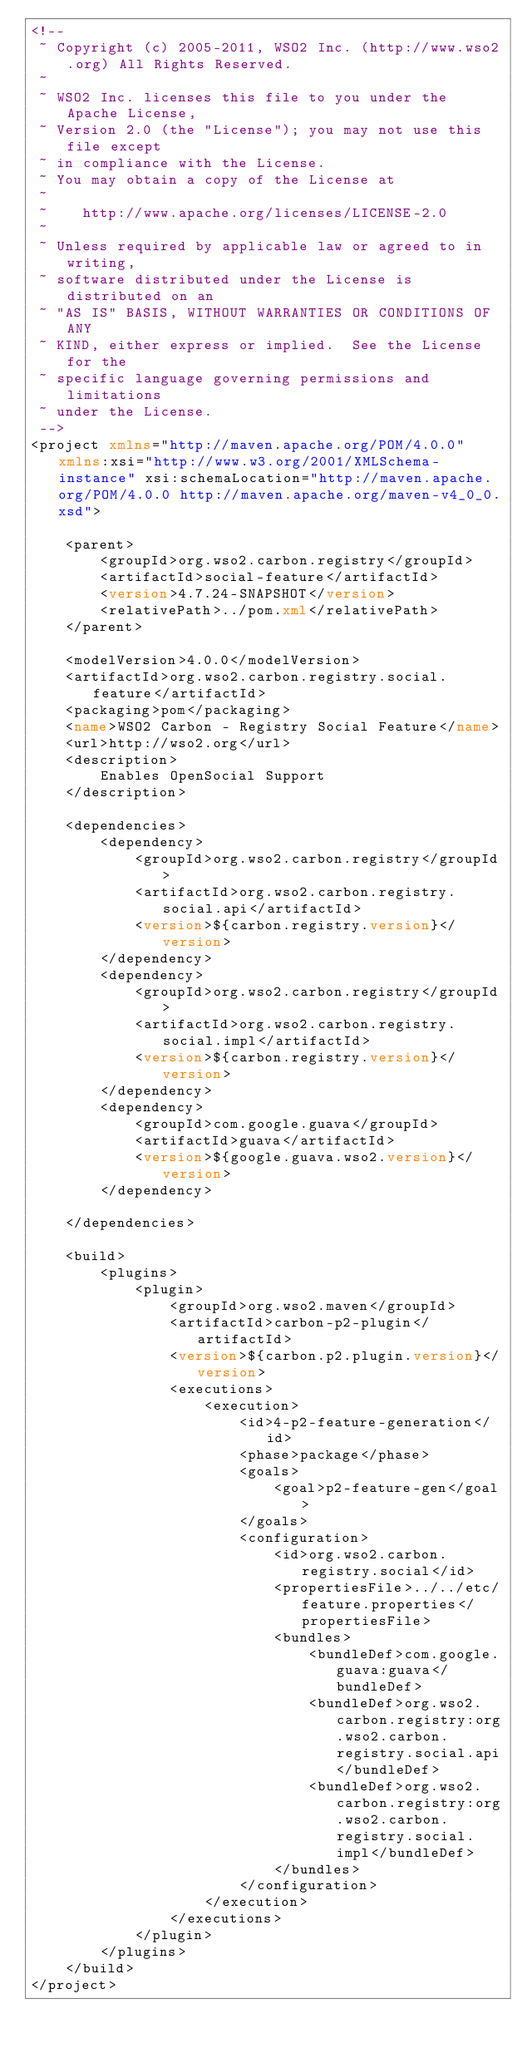Convert code to text. <code><loc_0><loc_0><loc_500><loc_500><_XML_><!--
 ~ Copyright (c) 2005-2011, WSO2 Inc. (http://www.wso2.org) All Rights Reserved.
 ~
 ~ WSO2 Inc. licenses this file to you under the Apache License,
 ~ Version 2.0 (the "License"); you may not use this file except
 ~ in compliance with the License.
 ~ You may obtain a copy of the License at
 ~
 ~    http://www.apache.org/licenses/LICENSE-2.0
 ~
 ~ Unless required by applicable law or agreed to in writing,
 ~ software distributed under the License is distributed on an
 ~ "AS IS" BASIS, WITHOUT WARRANTIES OR CONDITIONS OF ANY
 ~ KIND, either express or implied.  See the License for the
 ~ specific language governing permissions and limitations
 ~ under the License.
 -->
<project xmlns="http://maven.apache.org/POM/4.0.0" xmlns:xsi="http://www.w3.org/2001/XMLSchema-instance" xsi:schemaLocation="http://maven.apache.org/POM/4.0.0 http://maven.apache.org/maven-v4_0_0.xsd">

    <parent>
        <groupId>org.wso2.carbon.registry</groupId>
        <artifactId>social-feature</artifactId>
        <version>4.7.24-SNAPSHOT</version>
        <relativePath>../pom.xml</relativePath>
    </parent>

    <modelVersion>4.0.0</modelVersion>
    <artifactId>org.wso2.carbon.registry.social.feature</artifactId>
    <packaging>pom</packaging>
    <name>WSO2 Carbon - Registry Social Feature</name>
    <url>http://wso2.org</url>
    <description>
        Enables OpenSocial Support
    </description>

    <dependencies>
        <dependency>
            <groupId>org.wso2.carbon.registry</groupId>
            <artifactId>org.wso2.carbon.registry.social.api</artifactId>
            <version>${carbon.registry.version}</version>
        </dependency>
        <dependency>
            <groupId>org.wso2.carbon.registry</groupId>
            <artifactId>org.wso2.carbon.registry.social.impl</artifactId>
            <version>${carbon.registry.version}</version>
        </dependency>
        <dependency>
            <groupId>com.google.guava</groupId>
            <artifactId>guava</artifactId>
            <version>${google.guava.wso2.version}</version>
        </dependency>

    </dependencies>

    <build>
        <plugins>
            <plugin>
                <groupId>org.wso2.maven</groupId>
                <artifactId>carbon-p2-plugin</artifactId>
                <version>${carbon.p2.plugin.version}</version>
                <executions>
                    <execution>
                        <id>4-p2-feature-generation</id>
                        <phase>package</phase>
                        <goals>
                            <goal>p2-feature-gen</goal>
                        </goals>
                        <configuration>
                            <id>org.wso2.carbon.registry.social</id>
                            <propertiesFile>../../etc/feature.properties</propertiesFile>
                            <bundles>
                                <bundleDef>com.google.guava:guava</bundleDef>
                                <bundleDef>org.wso2.carbon.registry:org.wso2.carbon.registry.social.api</bundleDef>
                                <bundleDef>org.wso2.carbon.registry:org.wso2.carbon.registry.social.impl</bundleDef>
                            </bundles>
                        </configuration>
                    </execution>
                </executions>
            </plugin>
        </plugins>
    </build>
</project>
</code> 